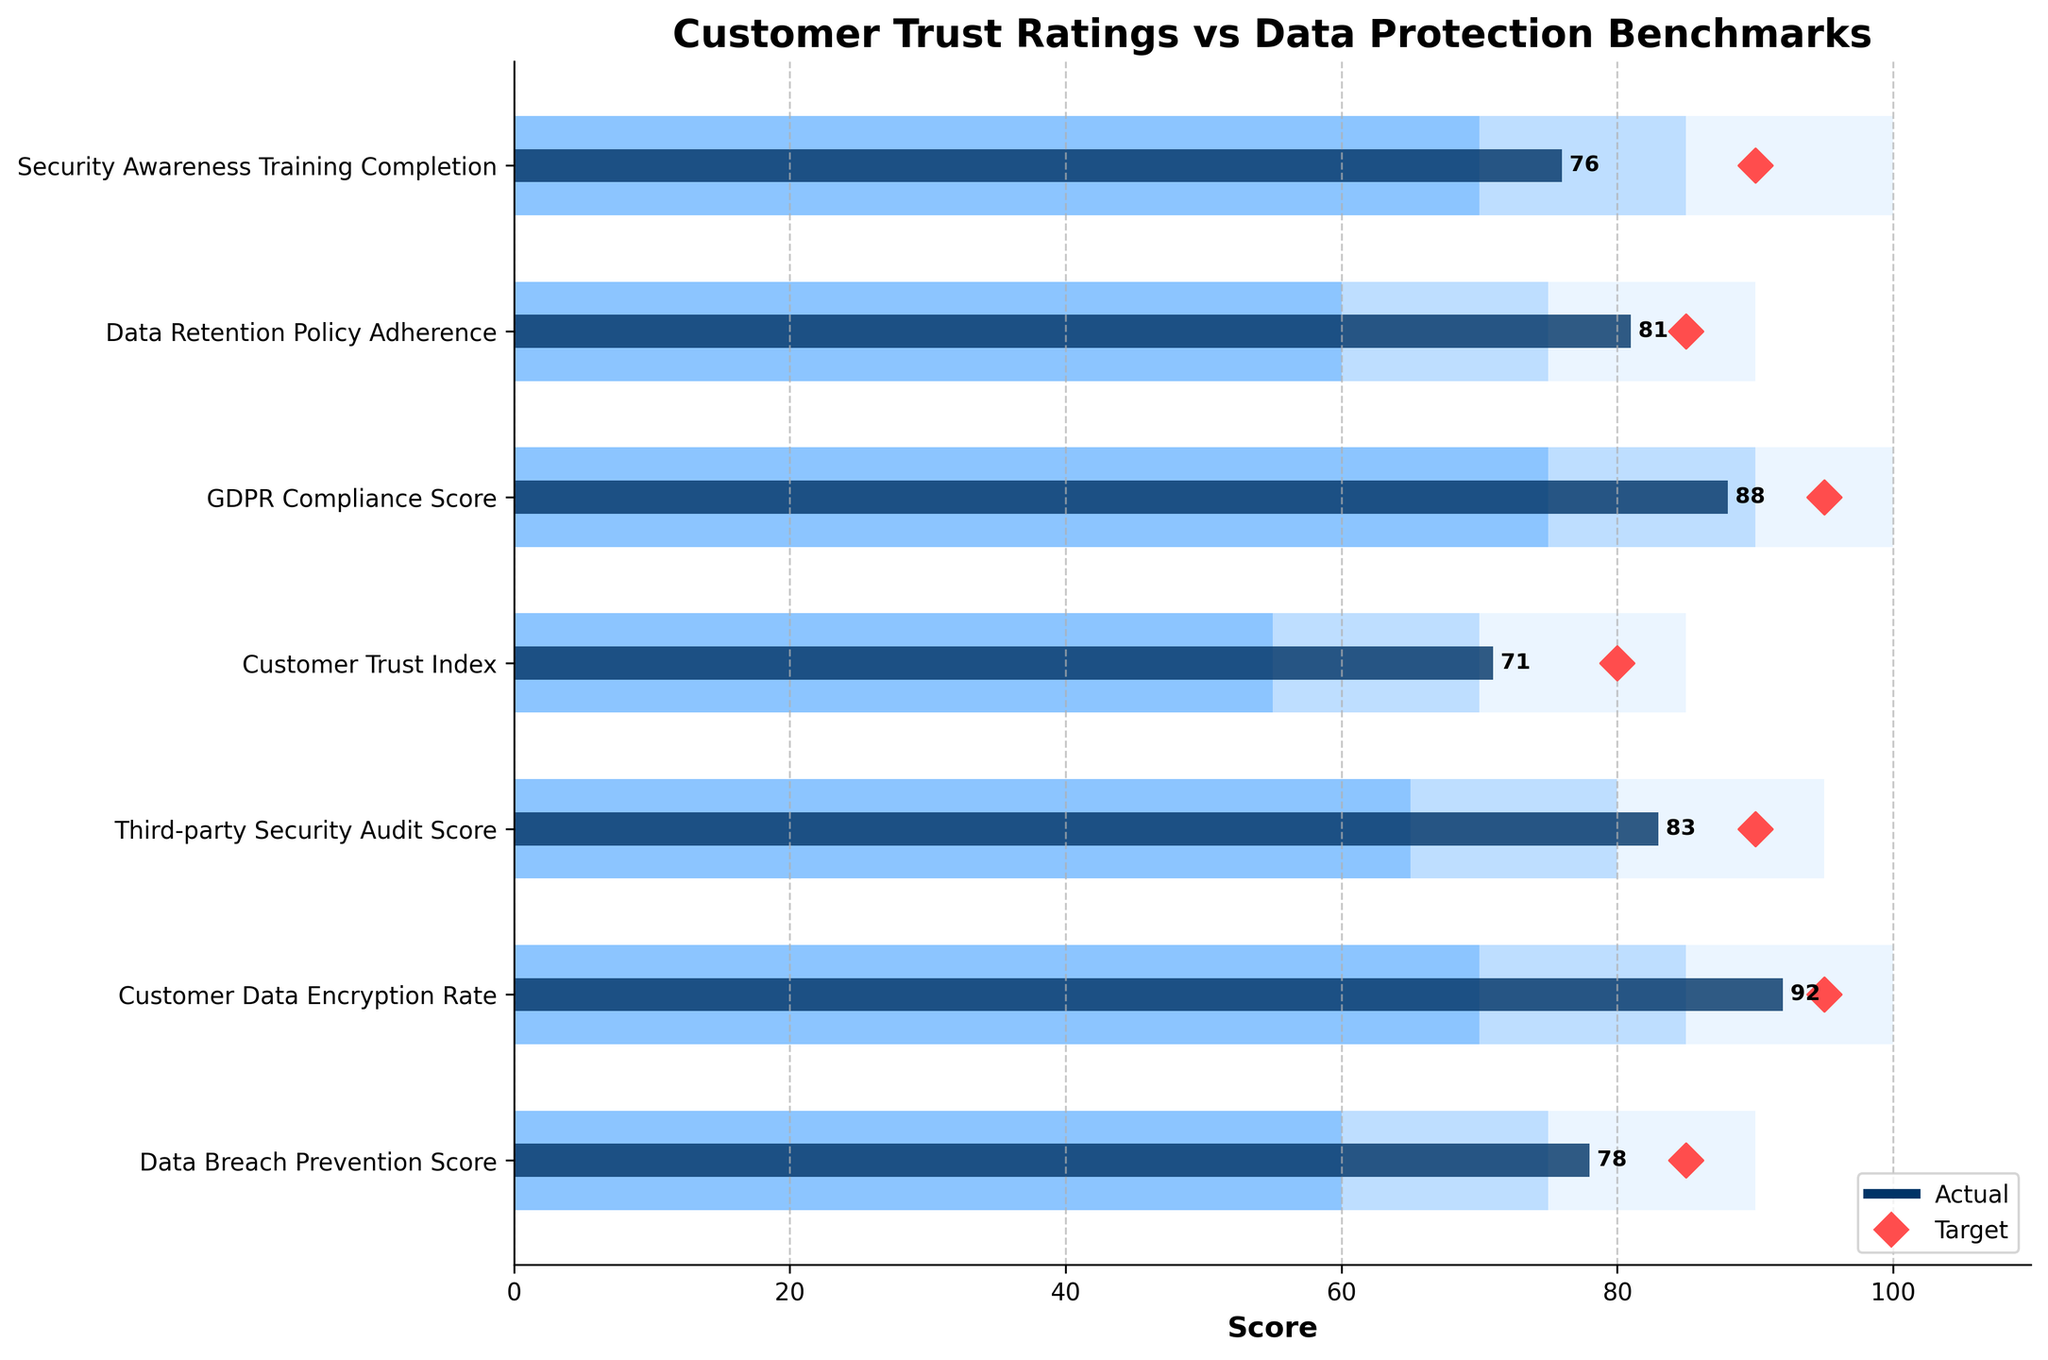What is the title of the figure? The title of the figure is located at the top and states the main purpose of the visual.
Answer: Customer Trust Ratings vs Data Protection Benchmarks How many metrics are shown in this bullet chart? Count the number of unique metric labels on the Y-axis. There are 7 metric labels listed from top to bottom.
Answer: 7 Which metric has the highest 'Actual' score? Look for the longest bar representing the 'Actual' score and check its metric label. The 'Customer Data Encryption Rate' has the highest actual score of 92.
Answer: Customer Data Encryption Rate Which metric has the closest 'Actual' score to its 'Target'? Compare the differences between 'Actual' and 'Target' scores for each metric and identify the smallest difference. 'Third-party Security Audit Score' has an 'Actual' score of 83 and a 'Target' of 90, resulting in a difference of 7, which is the smallest.
Answer: Third-party Security Audit Score Which metric's 'Actual' score falls within the 'Satisfactory' range? Check where the 'Actual' values lie within the 'Satisfactory' range by comparing it to the bar colors. 'Customer Trust Index' with an actual score of 71 falls within its ‘Satisfactory’ range of 55 to 70.
Answer: Customer Trust Index How many metrics have exceeded the 'Poor' benchmark? Count the number of metrics where the 'Actual' score is greater than their respective 'Poor' benchmark ranges. All 7 metrics exceed their 'Poor' benchmarks.
Answer: 7 What is the difference between the 'Actual' and 'Target' scores for "Security Awareness Training Completion"? Subtract the 'Actual' score from the 'Target' score for this metric. (90 - 76 = 14)
Answer: 14 Which metrics have 'Actual' scores that need the most improvement to meet their 'Target'? Identify the metrics with the largest gaps between 'Actual' and 'Target' by calculating the differences, then identify the largest ones. The largest gap is 'Security Awareness Training Completion' with a difference of 14.
Answer: Security Awareness Training Completion Does any metric meet or exceed its 'Excellent' benchmark? Compare the 'Actual' scores with the 'Excellent' benchmarks for all metrics. None of the 'Actual' scores meet or exceed their 'Excellent' benchmarks.
Answer: No 